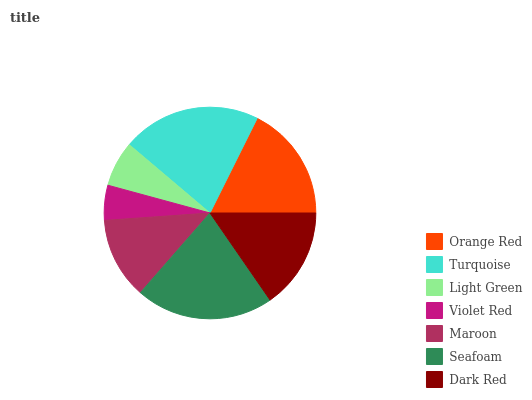Is Violet Red the minimum?
Answer yes or no. Yes. Is Turquoise the maximum?
Answer yes or no. Yes. Is Light Green the minimum?
Answer yes or no. No. Is Light Green the maximum?
Answer yes or no. No. Is Turquoise greater than Light Green?
Answer yes or no. Yes. Is Light Green less than Turquoise?
Answer yes or no. Yes. Is Light Green greater than Turquoise?
Answer yes or no. No. Is Turquoise less than Light Green?
Answer yes or no. No. Is Dark Red the high median?
Answer yes or no. Yes. Is Dark Red the low median?
Answer yes or no. Yes. Is Orange Red the high median?
Answer yes or no. No. Is Turquoise the low median?
Answer yes or no. No. 